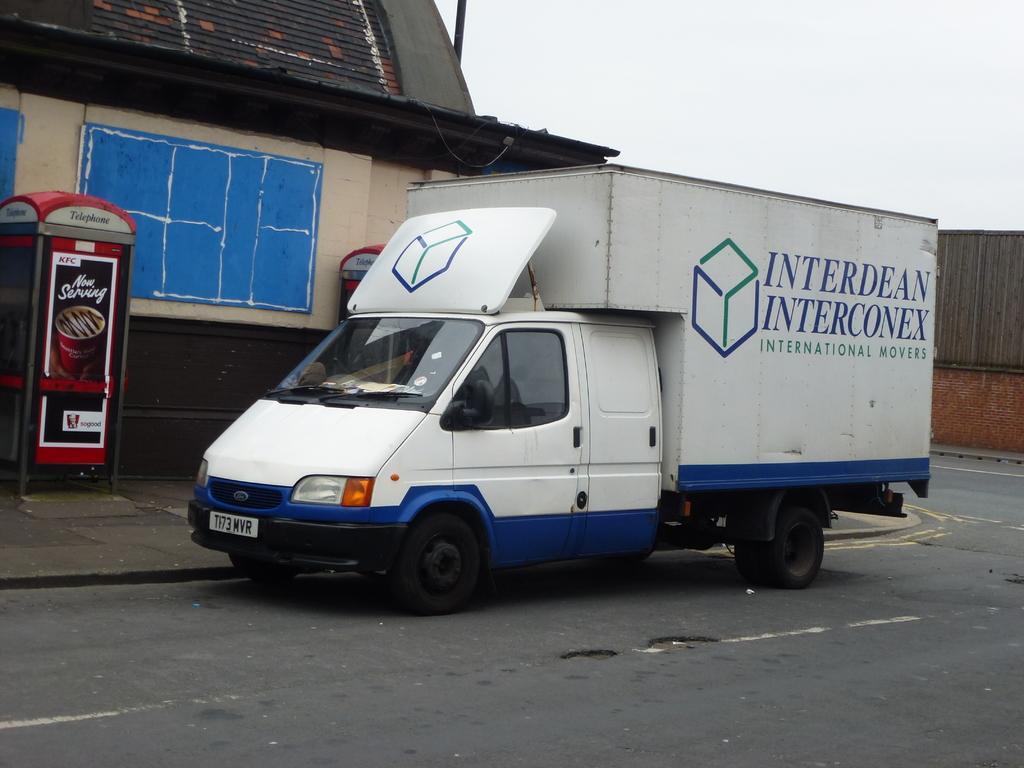Describe this image in one or two sentences. In this image we can see a motor vehicle on the road, telephone booths, shed and sky in the background. 